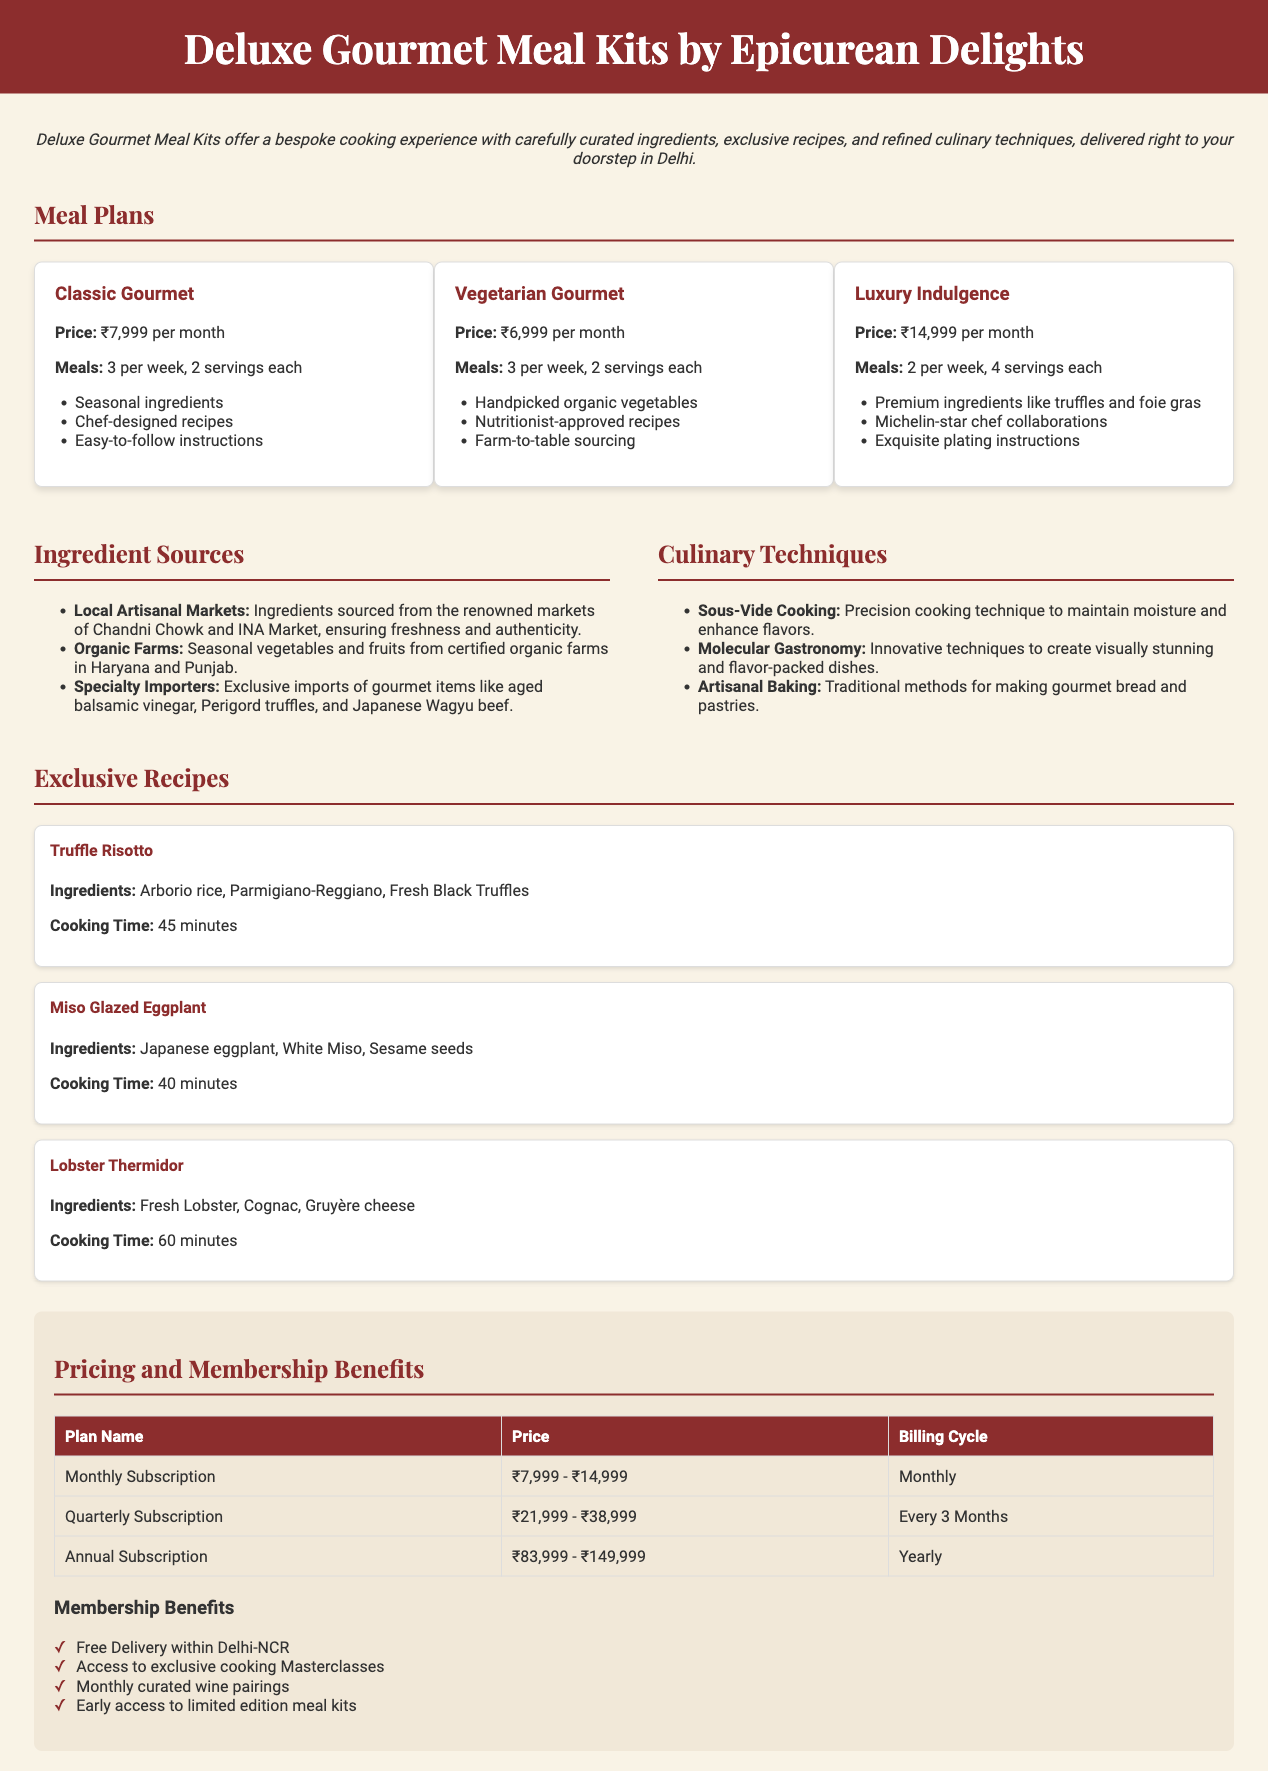What is the price of the Classic Gourmet meal plan? The price of the Classic Gourmet meal plan is listed in the meal plans section of the document, which states it is ₹7,999 per month.
Answer: ₹7,999 How many servings does the Luxury Indulgence plan provide? The Luxury Indulgence plan provides 4 servings each, as mentioned in the description of this plan.
Answer: 4 servings Where are the organic vegetables sourced from? The source of organic vegetables is described under ingredient sources in the document, specifying they come from certified organic farms in Haryana and Punjab.
Answer: Haryana and Punjab What culinary technique is used to maintain moisture in cooking? The document mentions Sous-Vide Cooking as the precision cooking technique used to maintain moisture.
Answer: Sous-Vide Cooking What is the cooking time for Lobster Thermidor? The cooking time for Lobster Thermidor is detailed in the recipes section of the document, which indicates it takes 60 minutes.
Answer: 60 minutes What benefits come with the membership? Membership benefits are listed at the bottom of the document, stating they include various perks such as free delivery and access to cooking masterclasses.
Answer: Free Delivery within Delhi-NCR, Access to exclusive cooking Masterclasses, Monthly curated wine pairings, Early access to limited edition meal kits How many meals per week does the Vegetarian Gourmet plan offer? The document specifies that the Vegetarian Gourmet meal plan offers 3 meals per week, as seen in its description.
Answer: 3 meals What is the pricing range for quarterly subscriptions? The quarterly subscription pricing is detailed in the pricing and benefits section, indicating a range of ₹21,999 to ₹38,999.
Answer: ₹21,999 - ₹38,999 Which meal plan features Michelin-star chef collaborations? The Luxury Indulgence meal plan is identified in the document as featuring collaborations with Michelin-star chefs.
Answer: Luxury Indulgence 